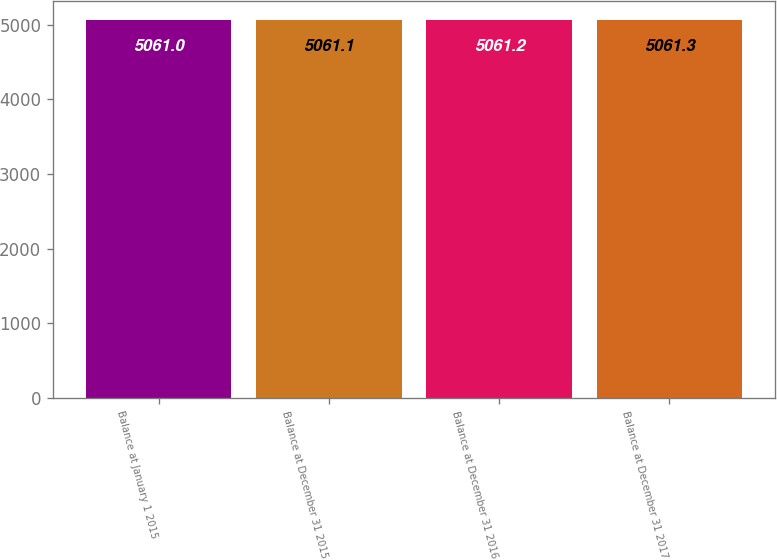Convert chart. <chart><loc_0><loc_0><loc_500><loc_500><bar_chart><fcel>Balance at January 1 2015<fcel>Balance at December 31 2015<fcel>Balance at December 31 2016<fcel>Balance at December 31 2017<nl><fcel>5061<fcel>5061.1<fcel>5061.2<fcel>5061.3<nl></chart> 